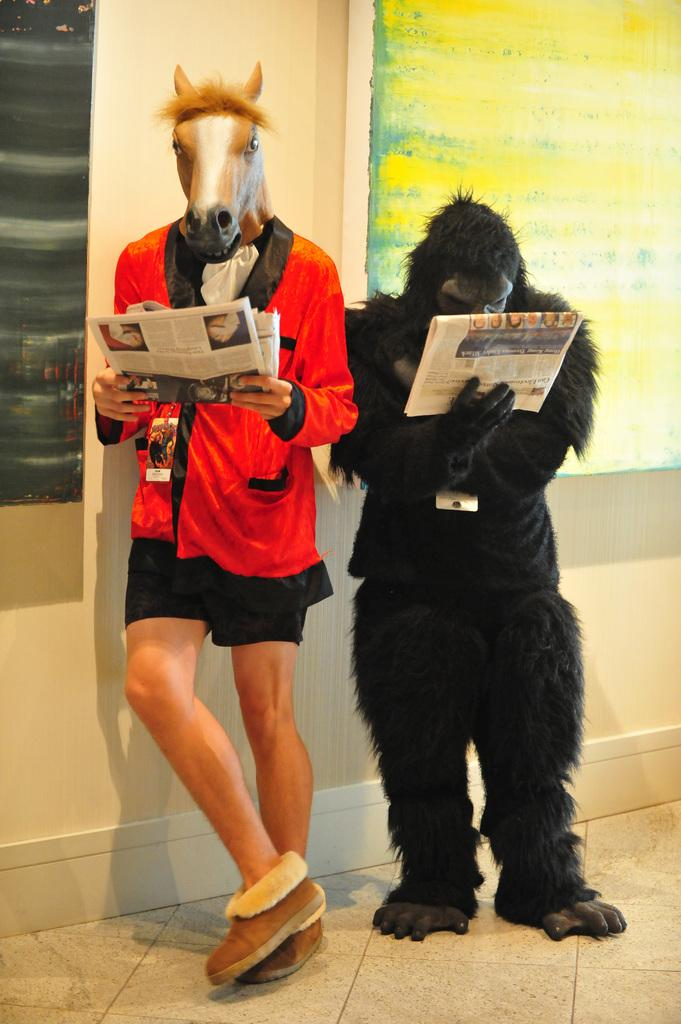How many people are in the image? There are two persons in the center of the image. What are the persons wearing? The persons are wearing masks. What are the persons holding in their hands? The persons are holding newspapers in their hands. What can be seen in the background of the image? There is a wall in the background of the image. What type of creature is hiding behind the wall in the image? There is no creature present in the image; it only features two persons wearing masks and holding newspapers. 